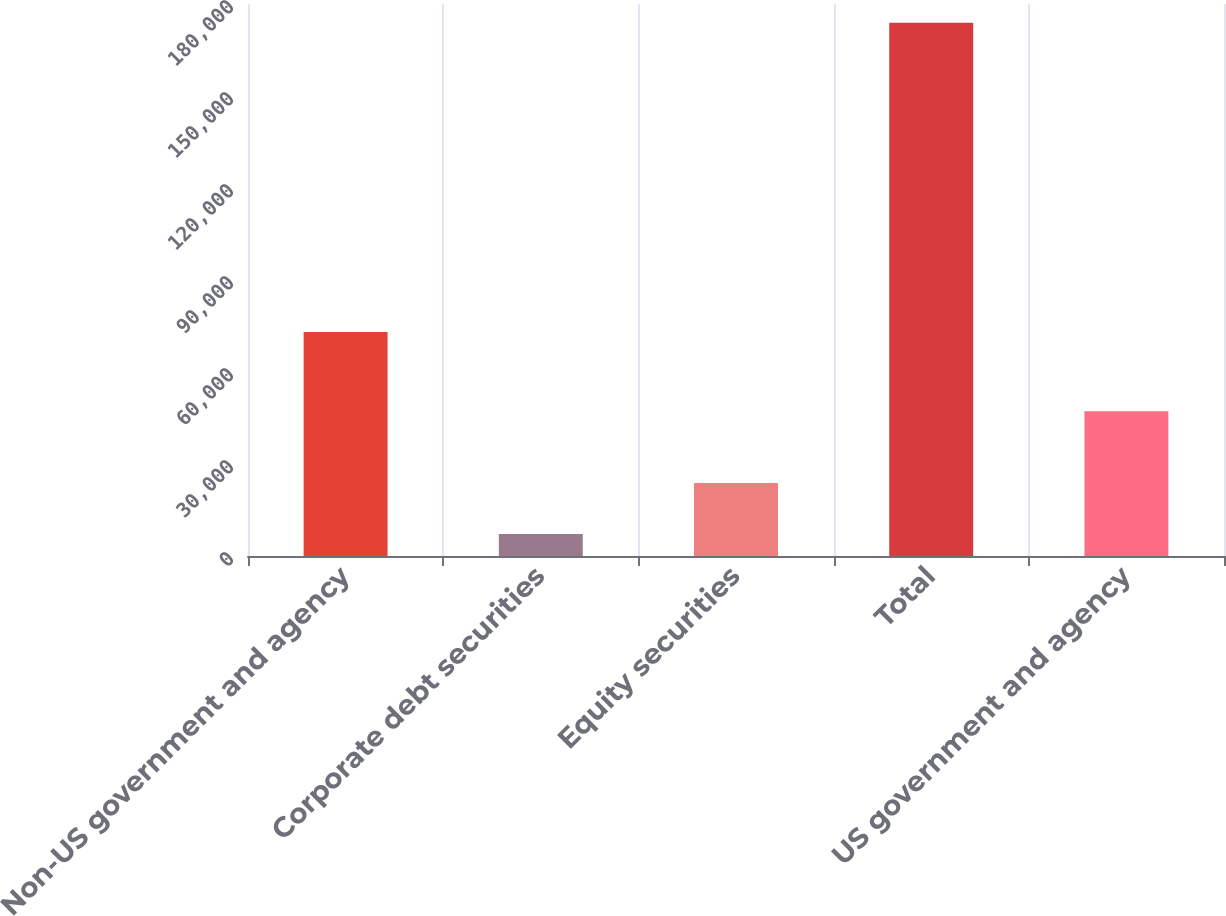<chart> <loc_0><loc_0><loc_500><loc_500><bar_chart><fcel>Non-US government and agency<fcel>Corporate debt securities<fcel>Equity securities<fcel>Total<fcel>US government and agency<nl><fcel>73031<fcel>7140<fcel>23812.8<fcel>173868<fcel>47207<nl></chart> 